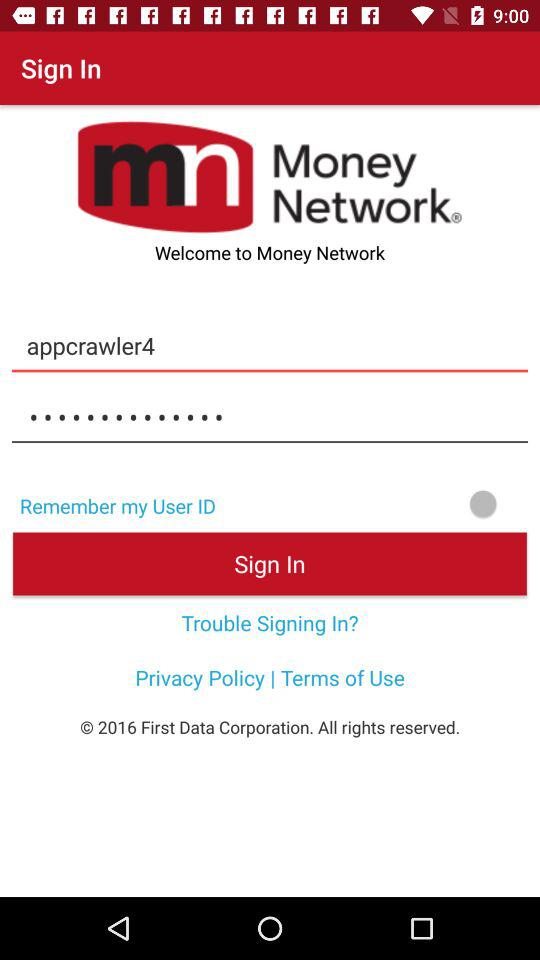What is the user name? The user name is Appcrawler4. 